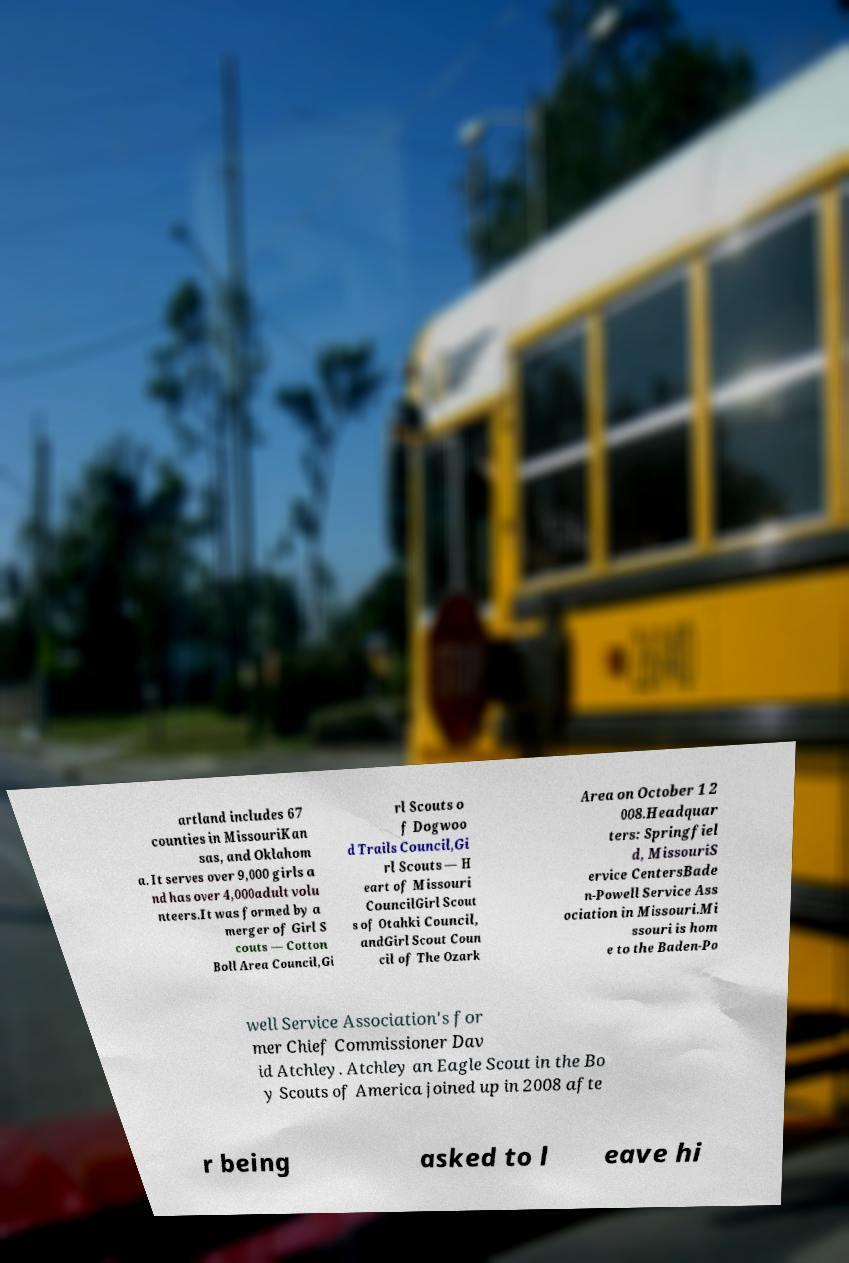Could you extract and type out the text from this image? artland includes 67 counties in MissouriKan sas, and Oklahom a. It serves over 9,000 girls a nd has over 4,000adult volu nteers.It was formed by a merger of Girl S couts — Cotton Boll Area Council,Gi rl Scouts o f Dogwoo d Trails Council,Gi rl Scouts — H eart of Missouri CouncilGirl Scout s of Otahki Council, andGirl Scout Coun cil of The Ozark Area on October 1 2 008.Headquar ters: Springfiel d, MissouriS ervice CentersBade n-Powell Service Ass ociation in Missouri.Mi ssouri is hom e to the Baden-Po well Service Association's for mer Chief Commissioner Dav id Atchley. Atchley an Eagle Scout in the Bo y Scouts of America joined up in 2008 afte r being asked to l eave hi 